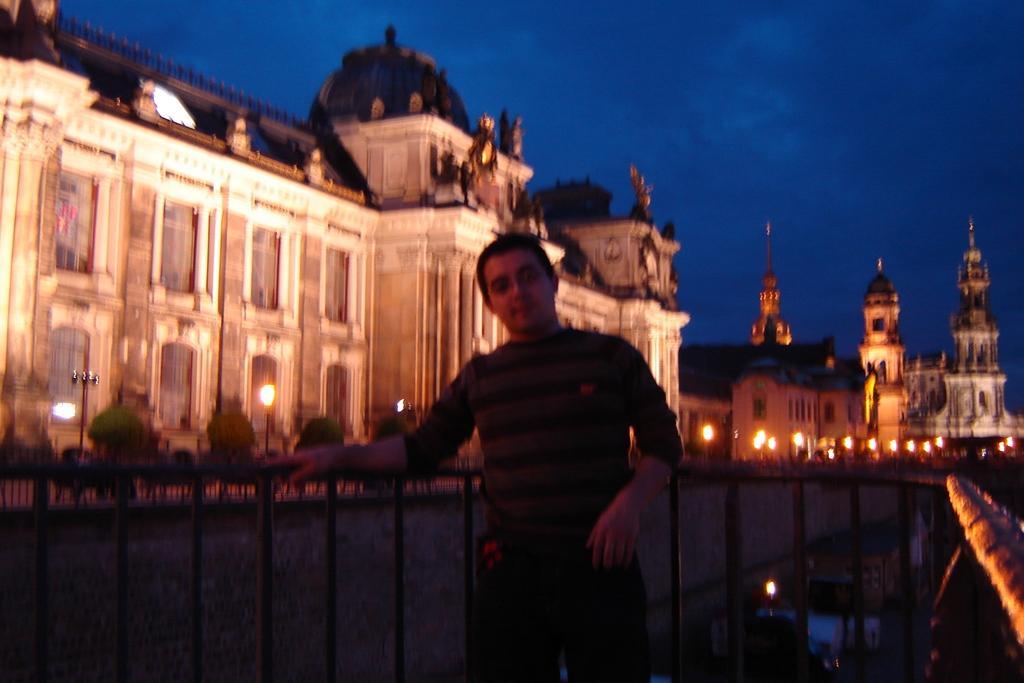Describe this image in one or two sentences. This picture shows few buildings and we see pole lights and few trees and a man standing and we see a metal fence and a blue sky. 